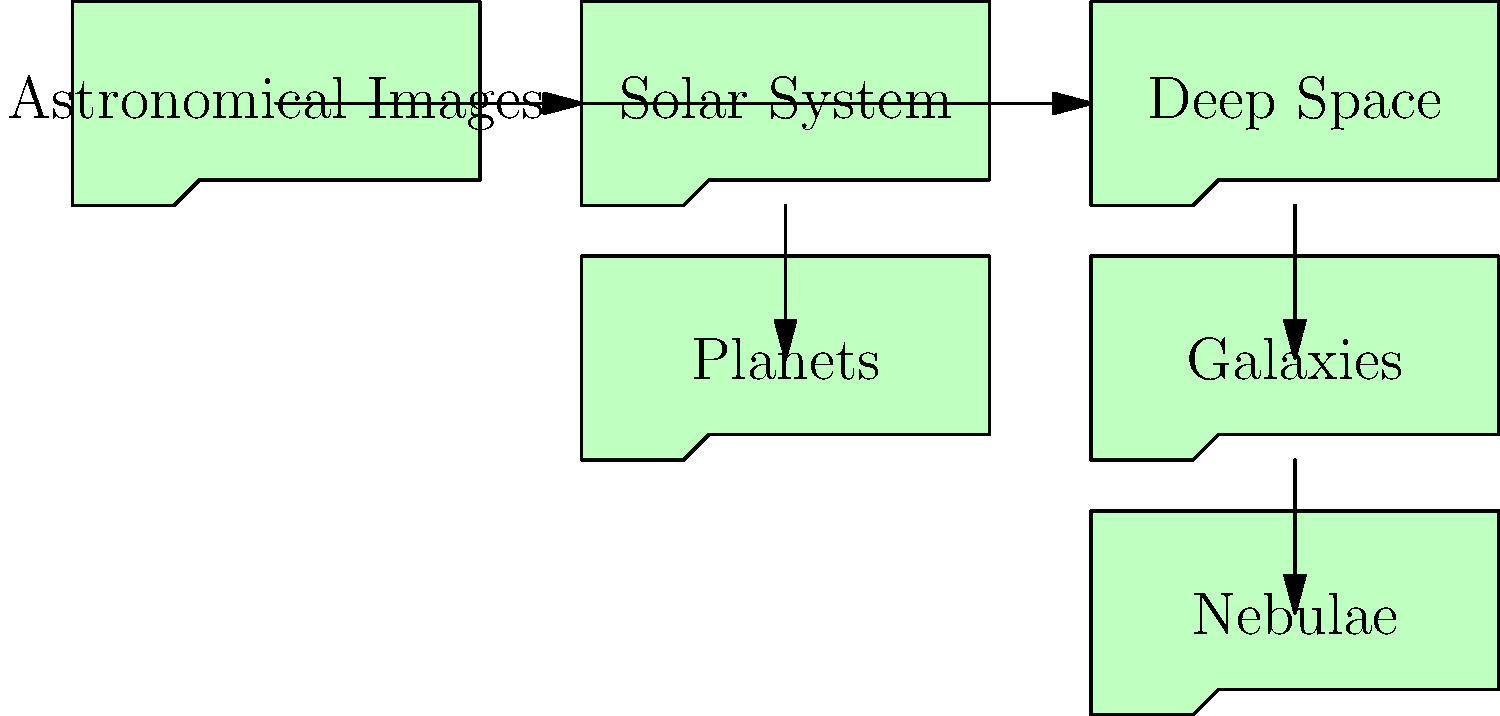As a project manager implementing an efficient file handling system for astronomical images, which of the following folder structures best represents a logical hierarchy for organizing various types of astronomical images? To organize astronomical images efficiently, we should follow a logical hierarchy that groups related images together. Let's break down the folder structure:

1. The root folder is "Astronomical Images," which encompasses all types of astronomical images.

2. Under the root, we have two main categories:
   a. "Solar System": For objects within our solar system
   b. "Deep Space": For objects beyond our solar system

3. Under "Solar System," we have a subfolder:
   a. "Planets": Specifically for images of planets in our solar system

4. Under "Deep Space," we have two subfolders:
   a. "Galaxies": For images of galaxies
   b. "Nebulae": For images of nebulae

This structure allows for easy navigation and categorization of different types of astronomical images. It separates nearby objects (Solar System) from distant objects (Deep Space) and further categorizes them into specific types (Planets, Galaxies, Nebulae).

The hierarchy can be expanded as needed, for example, by adding more subfolders under "Planets" for individual planets or including a "Stars" folder under "Deep Space" for stellar objects.
Answer: Hierarchical folder structure: Astronomical Images > (Solar System, Deep Space) > (Planets, Galaxies, Nebulae) 